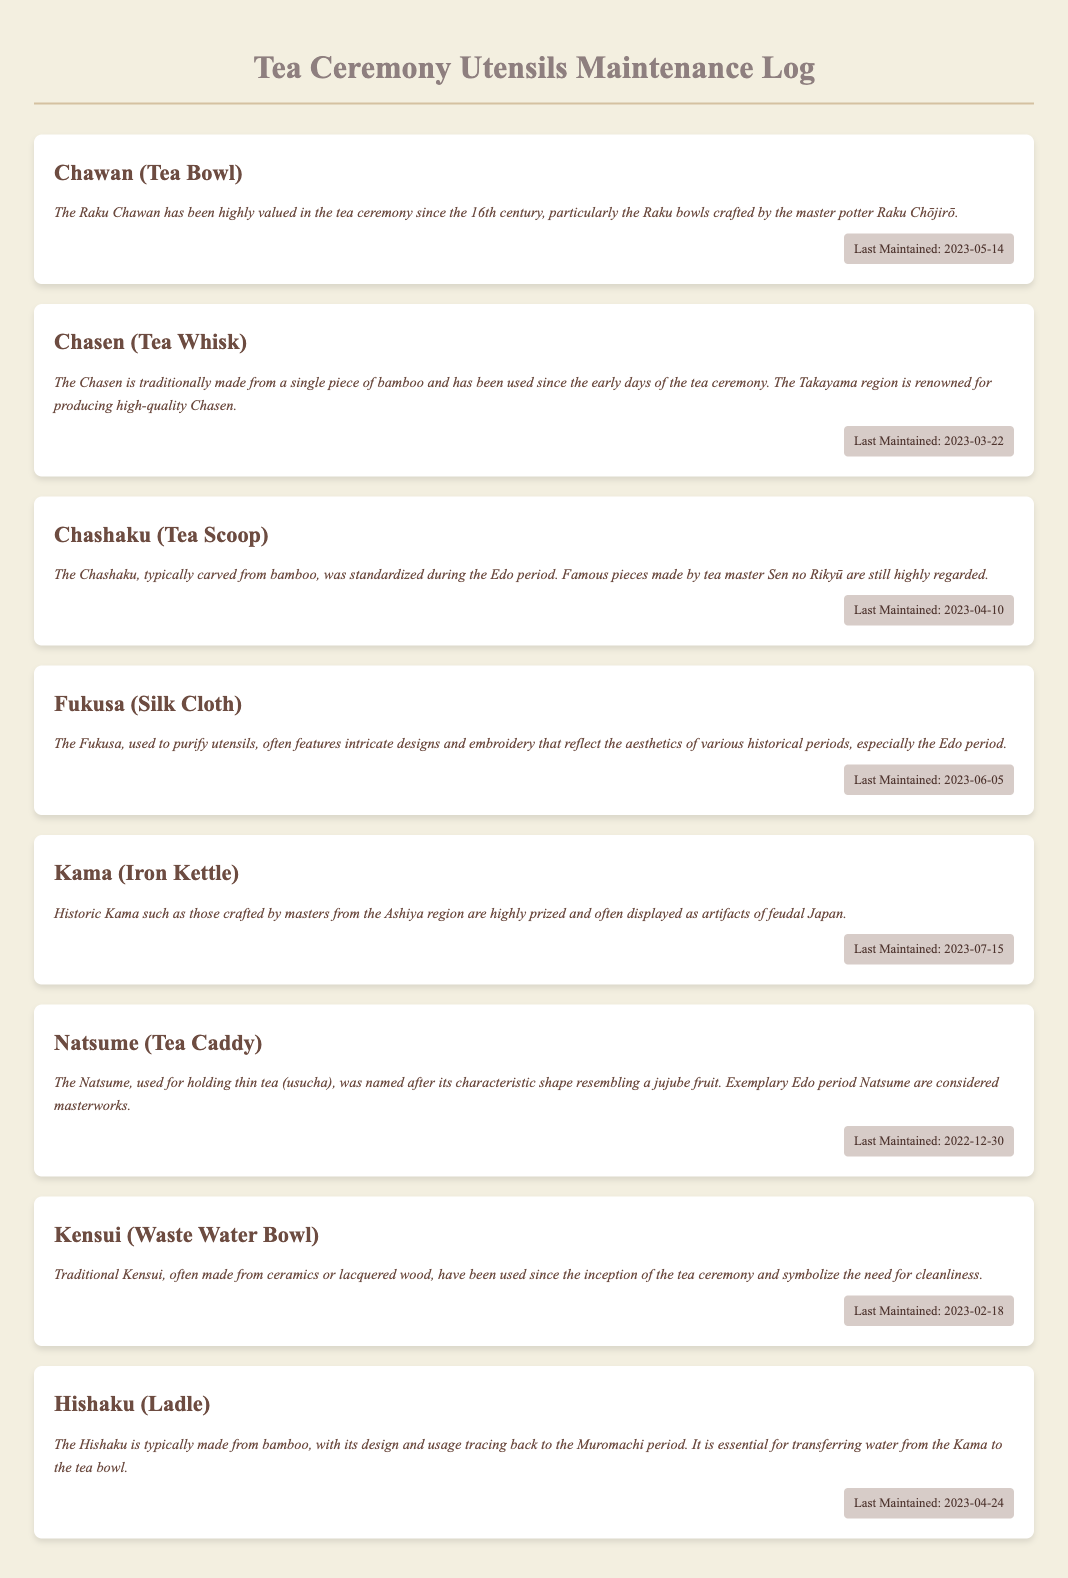What is the last maintenance date of the Chawan? The Chawan was last maintained on May 14, 2023, which is stated in the maintenance log entry.
Answer: 2023-05-14 What is the historical significance of the Chasen? The Chasen has been used since the early days of the tea ceremony and is noted for its quality from the Takayama region, indicating its long-standing importance.
Answer: Early days of the tea ceremony How many utensils have been maintained after April 2023? By checking the maintenance dates provided, there are four utensils maintained after April 2023: Chawan, Fukusa, Kama, and Hishaku.
Answer: 4 What utensil is used to purify other utensils? The Fukusa is specifically mentioned in the context of purifying utensils during the tea ceremony.
Answer: Fukusa When was the Natsume last maintained? The data states that the Natsume was last maintained on December 30, 2022, found in the maintenance entry for that utensil.
Answer: 2022-12-30 What kind of material is traditionally used to make the Hishaku? The Hishaku is typically made from bamboo, as noted in the historical annotation section of the maintenance log.
Answer: Bamboo Which utensil symbolizes cleanliness? The Kensui is mentioned to symbolize the need for cleanliness in the tea ceremony.
Answer: Kensui What is a common feature of the historical significance of the Chashaku? The Chashaku was standardized during the Edo period and pieces made by Sen no Rikyū are still highly regarded, emphasizing its cultural relevance.
Answer: Edo period 